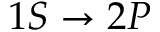<formula> <loc_0><loc_0><loc_500><loc_500>1 S \rightarrow 2 P</formula> 